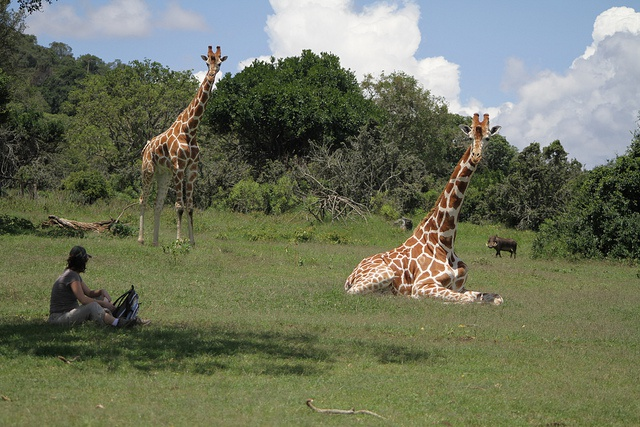Describe the objects in this image and their specific colors. I can see giraffe in darkgreen, gray, ivory, and maroon tones, giraffe in darkgreen, gray, black, and maroon tones, people in darkgreen, black, and gray tones, and backpack in darkgreen, black, gray, and darkblue tones in this image. 